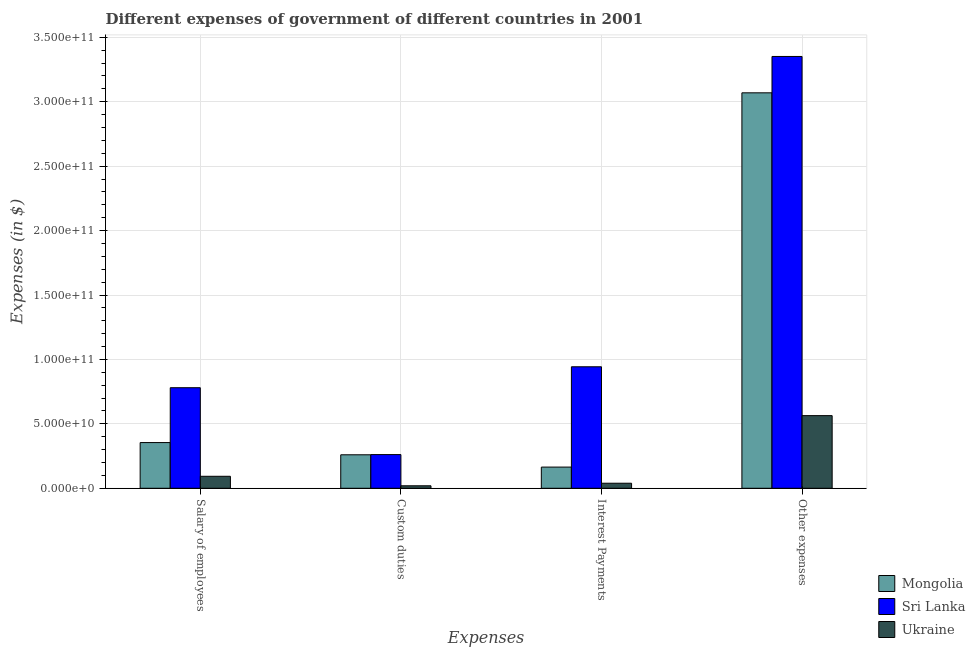How many groups of bars are there?
Your answer should be very brief. 4. How many bars are there on the 2nd tick from the left?
Ensure brevity in your answer.  3. What is the label of the 4th group of bars from the left?
Your answer should be very brief. Other expenses. What is the amount spent on other expenses in Mongolia?
Offer a terse response. 3.07e+11. Across all countries, what is the maximum amount spent on other expenses?
Your answer should be very brief. 3.35e+11. Across all countries, what is the minimum amount spent on custom duties?
Provide a short and direct response. 1.94e+09. In which country was the amount spent on salary of employees maximum?
Keep it short and to the point. Sri Lanka. In which country was the amount spent on interest payments minimum?
Give a very brief answer. Ukraine. What is the total amount spent on interest payments in the graph?
Provide a short and direct response. 1.15e+11. What is the difference between the amount spent on interest payments in Sri Lanka and that in Mongolia?
Keep it short and to the point. 7.79e+1. What is the difference between the amount spent on custom duties in Mongolia and the amount spent on interest payments in Sri Lanka?
Make the answer very short. -6.83e+1. What is the average amount spent on interest payments per country?
Your response must be concise. 3.82e+1. What is the difference between the amount spent on interest payments and amount spent on other expenses in Ukraine?
Provide a short and direct response. -5.25e+1. In how many countries, is the amount spent on interest payments greater than 60000000000 $?
Provide a succinct answer. 1. What is the ratio of the amount spent on salary of employees in Sri Lanka to that in Mongolia?
Your response must be concise. 2.2. Is the difference between the amount spent on other expenses in Ukraine and Mongolia greater than the difference between the amount spent on custom duties in Ukraine and Mongolia?
Your answer should be compact. No. What is the difference between the highest and the second highest amount spent on other expenses?
Offer a very short reply. 2.82e+1. What is the difference between the highest and the lowest amount spent on salary of employees?
Your answer should be very brief. 6.87e+1. In how many countries, is the amount spent on salary of employees greater than the average amount spent on salary of employees taken over all countries?
Ensure brevity in your answer.  1. Is the sum of the amount spent on salary of employees in Ukraine and Sri Lanka greater than the maximum amount spent on custom duties across all countries?
Your answer should be very brief. Yes. What does the 1st bar from the left in Interest Payments represents?
Offer a very short reply. Mongolia. What does the 3rd bar from the right in Salary of employees represents?
Offer a very short reply. Mongolia. How many bars are there?
Your answer should be compact. 12. How many countries are there in the graph?
Give a very brief answer. 3. Are the values on the major ticks of Y-axis written in scientific E-notation?
Your answer should be very brief. Yes. Does the graph contain any zero values?
Keep it short and to the point. No. Does the graph contain grids?
Your answer should be compact. Yes. Where does the legend appear in the graph?
Give a very brief answer. Bottom right. How are the legend labels stacked?
Ensure brevity in your answer.  Vertical. What is the title of the graph?
Provide a short and direct response. Different expenses of government of different countries in 2001. What is the label or title of the X-axis?
Offer a very short reply. Expenses. What is the label or title of the Y-axis?
Ensure brevity in your answer.  Expenses (in $). What is the Expenses (in $) in Mongolia in Salary of employees?
Your answer should be very brief. 3.55e+1. What is the Expenses (in $) in Sri Lanka in Salary of employees?
Provide a succinct answer. 7.81e+1. What is the Expenses (in $) in Ukraine in Salary of employees?
Keep it short and to the point. 9.31e+09. What is the Expenses (in $) in Mongolia in Custom duties?
Provide a succinct answer. 2.60e+1. What is the Expenses (in $) in Sri Lanka in Custom duties?
Provide a succinct answer. 2.62e+1. What is the Expenses (in $) of Ukraine in Custom duties?
Keep it short and to the point. 1.94e+09. What is the Expenses (in $) in Mongolia in Interest Payments?
Your response must be concise. 1.64e+1. What is the Expenses (in $) in Sri Lanka in Interest Payments?
Ensure brevity in your answer.  9.43e+1. What is the Expenses (in $) of Ukraine in Interest Payments?
Keep it short and to the point. 3.92e+09. What is the Expenses (in $) in Mongolia in Other expenses?
Provide a succinct answer. 3.07e+11. What is the Expenses (in $) in Sri Lanka in Other expenses?
Provide a short and direct response. 3.35e+11. What is the Expenses (in $) of Ukraine in Other expenses?
Your response must be concise. 5.64e+1. Across all Expenses, what is the maximum Expenses (in $) of Mongolia?
Offer a terse response. 3.07e+11. Across all Expenses, what is the maximum Expenses (in $) in Sri Lanka?
Your answer should be compact. 3.35e+11. Across all Expenses, what is the maximum Expenses (in $) in Ukraine?
Offer a terse response. 5.64e+1. Across all Expenses, what is the minimum Expenses (in $) in Mongolia?
Offer a very short reply. 1.64e+1. Across all Expenses, what is the minimum Expenses (in $) in Sri Lanka?
Keep it short and to the point. 2.62e+1. Across all Expenses, what is the minimum Expenses (in $) of Ukraine?
Provide a short and direct response. 1.94e+09. What is the total Expenses (in $) in Mongolia in the graph?
Your answer should be very brief. 3.85e+11. What is the total Expenses (in $) of Sri Lanka in the graph?
Provide a succinct answer. 5.34e+11. What is the total Expenses (in $) of Ukraine in the graph?
Provide a succinct answer. 7.16e+1. What is the difference between the Expenses (in $) of Mongolia in Salary of employees and that in Custom duties?
Offer a very short reply. 9.48e+09. What is the difference between the Expenses (in $) in Sri Lanka in Salary of employees and that in Custom duties?
Offer a terse response. 5.19e+1. What is the difference between the Expenses (in $) of Ukraine in Salary of employees and that in Custom duties?
Your answer should be very brief. 7.37e+09. What is the difference between the Expenses (in $) of Mongolia in Salary of employees and that in Interest Payments?
Offer a terse response. 1.90e+1. What is the difference between the Expenses (in $) in Sri Lanka in Salary of employees and that in Interest Payments?
Your answer should be very brief. -1.63e+1. What is the difference between the Expenses (in $) in Ukraine in Salary of employees and that in Interest Payments?
Your answer should be very brief. 5.39e+09. What is the difference between the Expenses (in $) in Mongolia in Salary of employees and that in Other expenses?
Offer a terse response. -2.71e+11. What is the difference between the Expenses (in $) of Sri Lanka in Salary of employees and that in Other expenses?
Your answer should be very brief. -2.57e+11. What is the difference between the Expenses (in $) in Ukraine in Salary of employees and that in Other expenses?
Offer a terse response. -4.71e+1. What is the difference between the Expenses (in $) in Mongolia in Custom duties and that in Interest Payments?
Provide a short and direct response. 9.54e+09. What is the difference between the Expenses (in $) of Sri Lanka in Custom duties and that in Interest Payments?
Offer a very short reply. -6.82e+1. What is the difference between the Expenses (in $) in Ukraine in Custom duties and that in Interest Payments?
Your response must be concise. -1.99e+09. What is the difference between the Expenses (in $) in Mongolia in Custom duties and that in Other expenses?
Ensure brevity in your answer.  -2.81e+11. What is the difference between the Expenses (in $) of Sri Lanka in Custom duties and that in Other expenses?
Provide a succinct answer. -3.09e+11. What is the difference between the Expenses (in $) in Ukraine in Custom duties and that in Other expenses?
Ensure brevity in your answer.  -5.44e+1. What is the difference between the Expenses (in $) of Mongolia in Interest Payments and that in Other expenses?
Your response must be concise. -2.90e+11. What is the difference between the Expenses (in $) in Sri Lanka in Interest Payments and that in Other expenses?
Provide a succinct answer. -2.41e+11. What is the difference between the Expenses (in $) in Ukraine in Interest Payments and that in Other expenses?
Give a very brief answer. -5.25e+1. What is the difference between the Expenses (in $) of Mongolia in Salary of employees and the Expenses (in $) of Sri Lanka in Custom duties?
Offer a very short reply. 9.32e+09. What is the difference between the Expenses (in $) of Mongolia in Salary of employees and the Expenses (in $) of Ukraine in Custom duties?
Your answer should be compact. 3.35e+1. What is the difference between the Expenses (in $) of Sri Lanka in Salary of employees and the Expenses (in $) of Ukraine in Custom duties?
Keep it short and to the point. 7.61e+1. What is the difference between the Expenses (in $) in Mongolia in Salary of employees and the Expenses (in $) in Sri Lanka in Interest Payments?
Keep it short and to the point. -5.88e+1. What is the difference between the Expenses (in $) in Mongolia in Salary of employees and the Expenses (in $) in Ukraine in Interest Payments?
Provide a succinct answer. 3.15e+1. What is the difference between the Expenses (in $) in Sri Lanka in Salary of employees and the Expenses (in $) in Ukraine in Interest Payments?
Ensure brevity in your answer.  7.41e+1. What is the difference between the Expenses (in $) in Mongolia in Salary of employees and the Expenses (in $) in Sri Lanka in Other expenses?
Give a very brief answer. -3.00e+11. What is the difference between the Expenses (in $) of Mongolia in Salary of employees and the Expenses (in $) of Ukraine in Other expenses?
Provide a succinct answer. -2.09e+1. What is the difference between the Expenses (in $) in Sri Lanka in Salary of employees and the Expenses (in $) in Ukraine in Other expenses?
Your response must be concise. 2.17e+1. What is the difference between the Expenses (in $) in Mongolia in Custom duties and the Expenses (in $) in Sri Lanka in Interest Payments?
Your answer should be compact. -6.83e+1. What is the difference between the Expenses (in $) in Mongolia in Custom duties and the Expenses (in $) in Ukraine in Interest Payments?
Your answer should be very brief. 2.21e+1. What is the difference between the Expenses (in $) of Sri Lanka in Custom duties and the Expenses (in $) of Ukraine in Interest Payments?
Offer a very short reply. 2.22e+1. What is the difference between the Expenses (in $) in Mongolia in Custom duties and the Expenses (in $) in Sri Lanka in Other expenses?
Your answer should be compact. -3.09e+11. What is the difference between the Expenses (in $) in Mongolia in Custom duties and the Expenses (in $) in Ukraine in Other expenses?
Keep it short and to the point. -3.04e+1. What is the difference between the Expenses (in $) of Sri Lanka in Custom duties and the Expenses (in $) of Ukraine in Other expenses?
Offer a very short reply. -3.02e+1. What is the difference between the Expenses (in $) in Mongolia in Interest Payments and the Expenses (in $) in Sri Lanka in Other expenses?
Give a very brief answer. -3.19e+11. What is the difference between the Expenses (in $) in Mongolia in Interest Payments and the Expenses (in $) in Ukraine in Other expenses?
Give a very brief answer. -3.99e+1. What is the difference between the Expenses (in $) in Sri Lanka in Interest Payments and the Expenses (in $) in Ukraine in Other expenses?
Your answer should be very brief. 3.79e+1. What is the average Expenses (in $) of Mongolia per Expenses?
Your answer should be very brief. 9.62e+1. What is the average Expenses (in $) in Sri Lanka per Expenses?
Make the answer very short. 1.33e+11. What is the average Expenses (in $) in Ukraine per Expenses?
Make the answer very short. 1.79e+1. What is the difference between the Expenses (in $) in Mongolia and Expenses (in $) in Sri Lanka in Salary of employees?
Make the answer very short. -4.26e+1. What is the difference between the Expenses (in $) of Mongolia and Expenses (in $) of Ukraine in Salary of employees?
Make the answer very short. 2.62e+1. What is the difference between the Expenses (in $) in Sri Lanka and Expenses (in $) in Ukraine in Salary of employees?
Offer a terse response. 6.87e+1. What is the difference between the Expenses (in $) of Mongolia and Expenses (in $) of Sri Lanka in Custom duties?
Give a very brief answer. -1.65e+08. What is the difference between the Expenses (in $) in Mongolia and Expenses (in $) in Ukraine in Custom duties?
Offer a terse response. 2.41e+1. What is the difference between the Expenses (in $) in Sri Lanka and Expenses (in $) in Ukraine in Custom duties?
Provide a succinct answer. 2.42e+1. What is the difference between the Expenses (in $) of Mongolia and Expenses (in $) of Sri Lanka in Interest Payments?
Your answer should be compact. -7.79e+1. What is the difference between the Expenses (in $) of Mongolia and Expenses (in $) of Ukraine in Interest Payments?
Your answer should be compact. 1.25e+1. What is the difference between the Expenses (in $) of Sri Lanka and Expenses (in $) of Ukraine in Interest Payments?
Make the answer very short. 9.04e+1. What is the difference between the Expenses (in $) in Mongolia and Expenses (in $) in Sri Lanka in Other expenses?
Your answer should be very brief. -2.82e+1. What is the difference between the Expenses (in $) of Mongolia and Expenses (in $) of Ukraine in Other expenses?
Give a very brief answer. 2.51e+11. What is the difference between the Expenses (in $) of Sri Lanka and Expenses (in $) of Ukraine in Other expenses?
Your answer should be very brief. 2.79e+11. What is the ratio of the Expenses (in $) of Mongolia in Salary of employees to that in Custom duties?
Offer a terse response. 1.36. What is the ratio of the Expenses (in $) of Sri Lanka in Salary of employees to that in Custom duties?
Your answer should be compact. 2.98. What is the ratio of the Expenses (in $) of Ukraine in Salary of employees to that in Custom duties?
Offer a terse response. 4.81. What is the ratio of the Expenses (in $) in Mongolia in Salary of employees to that in Interest Payments?
Offer a very short reply. 2.16. What is the ratio of the Expenses (in $) of Sri Lanka in Salary of employees to that in Interest Payments?
Make the answer very short. 0.83. What is the ratio of the Expenses (in $) in Ukraine in Salary of employees to that in Interest Payments?
Make the answer very short. 2.37. What is the ratio of the Expenses (in $) of Mongolia in Salary of employees to that in Other expenses?
Your answer should be compact. 0.12. What is the ratio of the Expenses (in $) of Sri Lanka in Salary of employees to that in Other expenses?
Your response must be concise. 0.23. What is the ratio of the Expenses (in $) of Ukraine in Salary of employees to that in Other expenses?
Keep it short and to the point. 0.17. What is the ratio of the Expenses (in $) in Mongolia in Custom duties to that in Interest Payments?
Your answer should be very brief. 1.58. What is the ratio of the Expenses (in $) of Sri Lanka in Custom duties to that in Interest Payments?
Your answer should be very brief. 0.28. What is the ratio of the Expenses (in $) in Ukraine in Custom duties to that in Interest Payments?
Your answer should be compact. 0.49. What is the ratio of the Expenses (in $) of Mongolia in Custom duties to that in Other expenses?
Make the answer very short. 0.08. What is the ratio of the Expenses (in $) in Sri Lanka in Custom duties to that in Other expenses?
Offer a terse response. 0.08. What is the ratio of the Expenses (in $) of Ukraine in Custom duties to that in Other expenses?
Keep it short and to the point. 0.03. What is the ratio of the Expenses (in $) in Mongolia in Interest Payments to that in Other expenses?
Offer a terse response. 0.05. What is the ratio of the Expenses (in $) of Sri Lanka in Interest Payments to that in Other expenses?
Your answer should be compact. 0.28. What is the ratio of the Expenses (in $) of Ukraine in Interest Payments to that in Other expenses?
Provide a short and direct response. 0.07. What is the difference between the highest and the second highest Expenses (in $) in Mongolia?
Offer a very short reply. 2.71e+11. What is the difference between the highest and the second highest Expenses (in $) in Sri Lanka?
Offer a very short reply. 2.41e+11. What is the difference between the highest and the second highest Expenses (in $) in Ukraine?
Offer a terse response. 4.71e+1. What is the difference between the highest and the lowest Expenses (in $) of Mongolia?
Offer a terse response. 2.90e+11. What is the difference between the highest and the lowest Expenses (in $) in Sri Lanka?
Keep it short and to the point. 3.09e+11. What is the difference between the highest and the lowest Expenses (in $) of Ukraine?
Provide a succinct answer. 5.44e+1. 